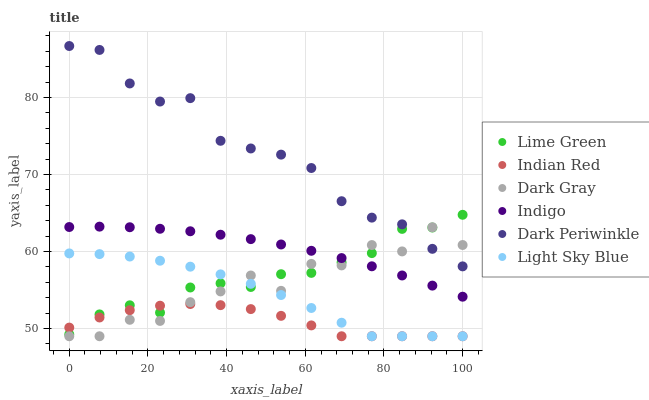Does Indian Red have the minimum area under the curve?
Answer yes or no. Yes. Does Dark Periwinkle have the maximum area under the curve?
Answer yes or no. Yes. Does Dark Gray have the minimum area under the curve?
Answer yes or no. No. Does Dark Gray have the maximum area under the curve?
Answer yes or no. No. Is Indigo the smoothest?
Answer yes or no. Yes. Is Dark Gray the roughest?
Answer yes or no. Yes. Is Light Sky Blue the smoothest?
Answer yes or no. No. Is Light Sky Blue the roughest?
Answer yes or no. No. Does Dark Gray have the lowest value?
Answer yes or no. Yes. Does Lime Green have the lowest value?
Answer yes or no. No. Does Dark Periwinkle have the highest value?
Answer yes or no. Yes. Does Dark Gray have the highest value?
Answer yes or no. No. Is Light Sky Blue less than Indigo?
Answer yes or no. Yes. Is Dark Periwinkle greater than Indian Red?
Answer yes or no. Yes. Does Dark Gray intersect Dark Periwinkle?
Answer yes or no. Yes. Is Dark Gray less than Dark Periwinkle?
Answer yes or no. No. Is Dark Gray greater than Dark Periwinkle?
Answer yes or no. No. Does Light Sky Blue intersect Indigo?
Answer yes or no. No. 